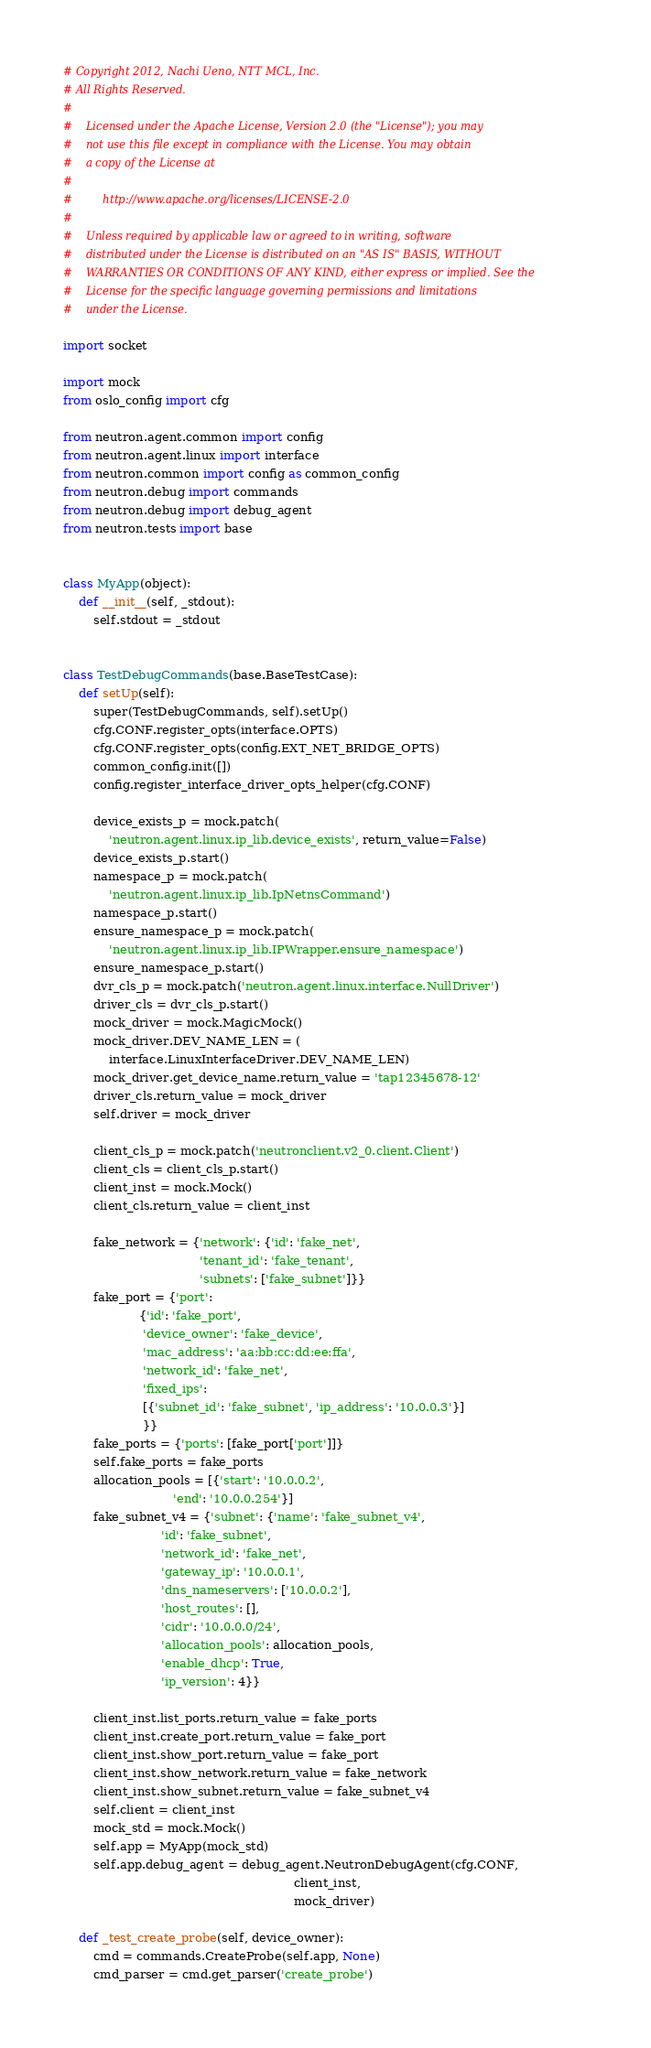<code> <loc_0><loc_0><loc_500><loc_500><_Python_># Copyright 2012, Nachi Ueno, NTT MCL, Inc.
# All Rights Reserved.
#
#    Licensed under the Apache License, Version 2.0 (the "License"); you may
#    not use this file except in compliance with the License. You may obtain
#    a copy of the License at
#
#         http://www.apache.org/licenses/LICENSE-2.0
#
#    Unless required by applicable law or agreed to in writing, software
#    distributed under the License is distributed on an "AS IS" BASIS, WITHOUT
#    WARRANTIES OR CONDITIONS OF ANY KIND, either express or implied. See the
#    License for the specific language governing permissions and limitations
#    under the License.

import socket

import mock
from oslo_config import cfg

from neutron.agent.common import config
from neutron.agent.linux import interface
from neutron.common import config as common_config
from neutron.debug import commands
from neutron.debug import debug_agent
from neutron.tests import base


class MyApp(object):
    def __init__(self, _stdout):
        self.stdout = _stdout


class TestDebugCommands(base.BaseTestCase):
    def setUp(self):
        super(TestDebugCommands, self).setUp()
        cfg.CONF.register_opts(interface.OPTS)
        cfg.CONF.register_opts(config.EXT_NET_BRIDGE_OPTS)
        common_config.init([])
        config.register_interface_driver_opts_helper(cfg.CONF)

        device_exists_p = mock.patch(
            'neutron.agent.linux.ip_lib.device_exists', return_value=False)
        device_exists_p.start()
        namespace_p = mock.patch(
            'neutron.agent.linux.ip_lib.IpNetnsCommand')
        namespace_p.start()
        ensure_namespace_p = mock.patch(
            'neutron.agent.linux.ip_lib.IPWrapper.ensure_namespace')
        ensure_namespace_p.start()
        dvr_cls_p = mock.patch('neutron.agent.linux.interface.NullDriver')
        driver_cls = dvr_cls_p.start()
        mock_driver = mock.MagicMock()
        mock_driver.DEV_NAME_LEN = (
            interface.LinuxInterfaceDriver.DEV_NAME_LEN)
        mock_driver.get_device_name.return_value = 'tap12345678-12'
        driver_cls.return_value = mock_driver
        self.driver = mock_driver

        client_cls_p = mock.patch('neutronclient.v2_0.client.Client')
        client_cls = client_cls_p.start()
        client_inst = mock.Mock()
        client_cls.return_value = client_inst

        fake_network = {'network': {'id': 'fake_net',
                                    'tenant_id': 'fake_tenant',
                                    'subnets': ['fake_subnet']}}
        fake_port = {'port':
                    {'id': 'fake_port',
                     'device_owner': 'fake_device',
                     'mac_address': 'aa:bb:cc:dd:ee:ffa',
                     'network_id': 'fake_net',
                     'fixed_ips':
                     [{'subnet_id': 'fake_subnet', 'ip_address': '10.0.0.3'}]
                     }}
        fake_ports = {'ports': [fake_port['port']]}
        self.fake_ports = fake_ports
        allocation_pools = [{'start': '10.0.0.2',
                             'end': '10.0.0.254'}]
        fake_subnet_v4 = {'subnet': {'name': 'fake_subnet_v4',
                          'id': 'fake_subnet',
                          'network_id': 'fake_net',
                          'gateway_ip': '10.0.0.1',
                          'dns_nameservers': ['10.0.0.2'],
                          'host_routes': [],
                          'cidr': '10.0.0.0/24',
                          'allocation_pools': allocation_pools,
                          'enable_dhcp': True,
                          'ip_version': 4}}

        client_inst.list_ports.return_value = fake_ports
        client_inst.create_port.return_value = fake_port
        client_inst.show_port.return_value = fake_port
        client_inst.show_network.return_value = fake_network
        client_inst.show_subnet.return_value = fake_subnet_v4
        self.client = client_inst
        mock_std = mock.Mock()
        self.app = MyApp(mock_std)
        self.app.debug_agent = debug_agent.NeutronDebugAgent(cfg.CONF,
                                                             client_inst,
                                                             mock_driver)

    def _test_create_probe(self, device_owner):
        cmd = commands.CreateProbe(self.app, None)
        cmd_parser = cmd.get_parser('create_probe')</code> 